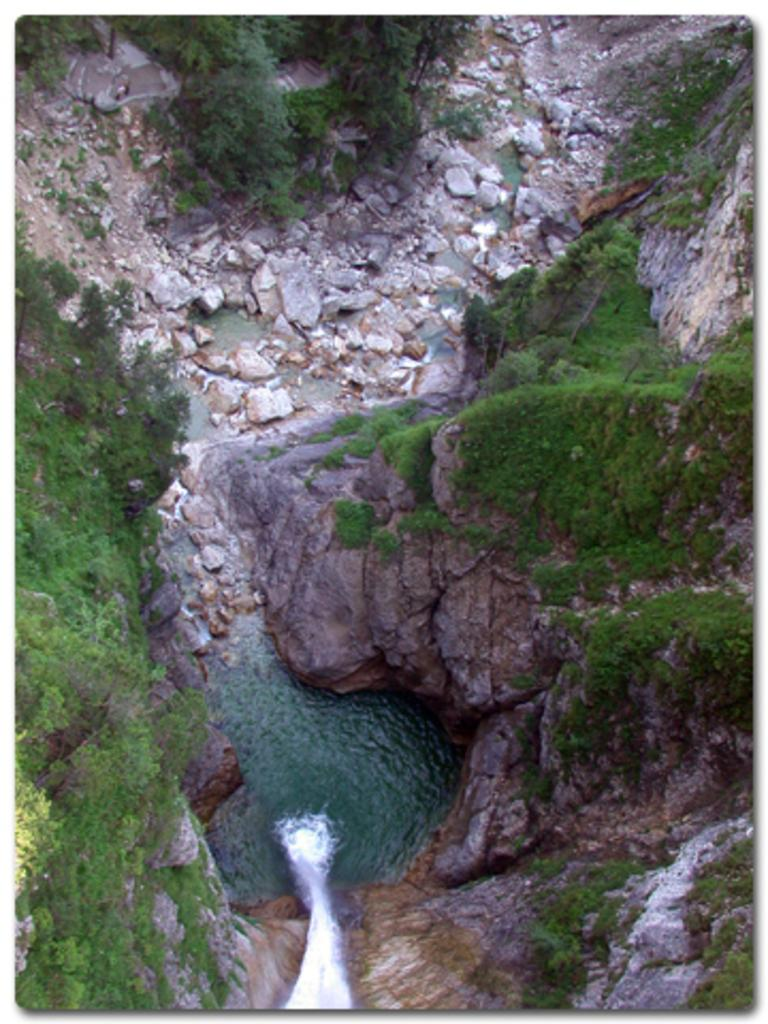What type of natural elements can be seen in the image? There are rocks, stones, plants, and a waterfall in the image. Can you describe the water feature in the image? There is a waterfall in the image. What type of vegetation is present in the image? There are plants in the image. What type of stick can be seen growing out of the waterfall in the image? There is no stick growing out of the waterfall in the image. 